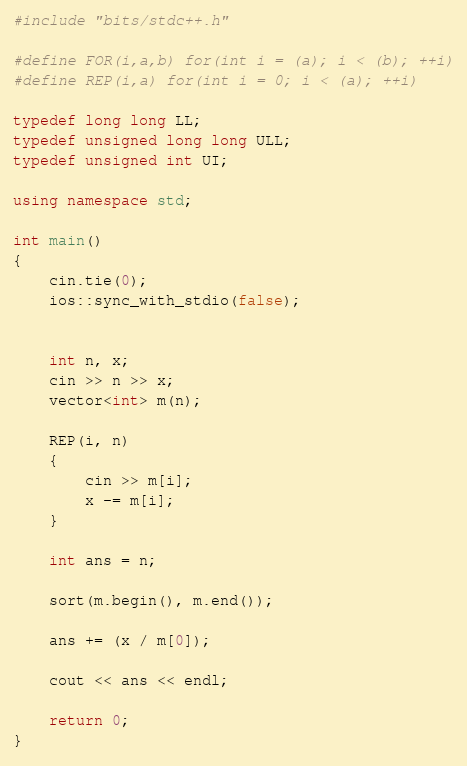Convert code to text. <code><loc_0><loc_0><loc_500><loc_500><_C++_>#include "bits/stdc++.h"

#define FOR(i,a,b) for(int i = (a); i < (b); ++i)
#define REP(i,a) for(int i = 0; i < (a); ++i)

typedef long long LL;
typedef unsigned long long ULL;
typedef unsigned int UI;

using namespace std;

int main()
{
    cin.tie(0);
    ios::sync_with_stdio(false);


    int n, x;
    cin >> n >> x;
    vector<int> m(n);

    REP(i, n)
    {
        cin >> m[i];
        x -= m[i];
    }

    int ans = n;

    sort(m.begin(), m.end());

    ans += (x / m[0]);

    cout << ans << endl;

    return 0;
}</code> 